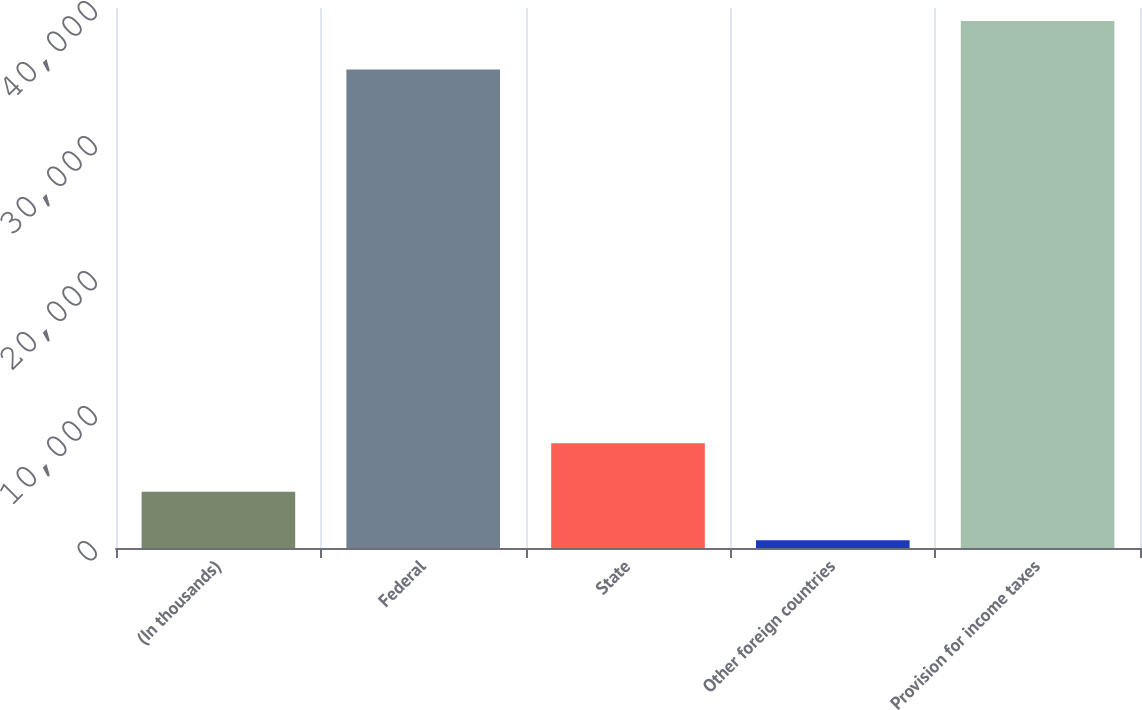Convert chart. <chart><loc_0><loc_0><loc_500><loc_500><bar_chart><fcel>(In thousands)<fcel>Federal<fcel>State<fcel>Other foreign countries<fcel>Provision for income taxes<nl><fcel>4160.6<fcel>35446<fcel>7752.2<fcel>569<fcel>39037.6<nl></chart> 